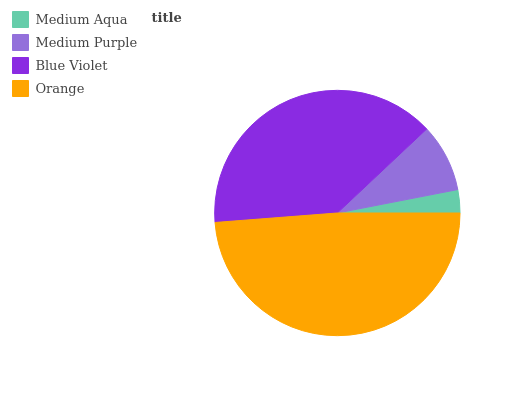Is Medium Aqua the minimum?
Answer yes or no. Yes. Is Orange the maximum?
Answer yes or no. Yes. Is Medium Purple the minimum?
Answer yes or no. No. Is Medium Purple the maximum?
Answer yes or no. No. Is Medium Purple greater than Medium Aqua?
Answer yes or no. Yes. Is Medium Aqua less than Medium Purple?
Answer yes or no. Yes. Is Medium Aqua greater than Medium Purple?
Answer yes or no. No. Is Medium Purple less than Medium Aqua?
Answer yes or no. No. Is Blue Violet the high median?
Answer yes or no. Yes. Is Medium Purple the low median?
Answer yes or no. Yes. Is Medium Purple the high median?
Answer yes or no. No. Is Blue Violet the low median?
Answer yes or no. No. 